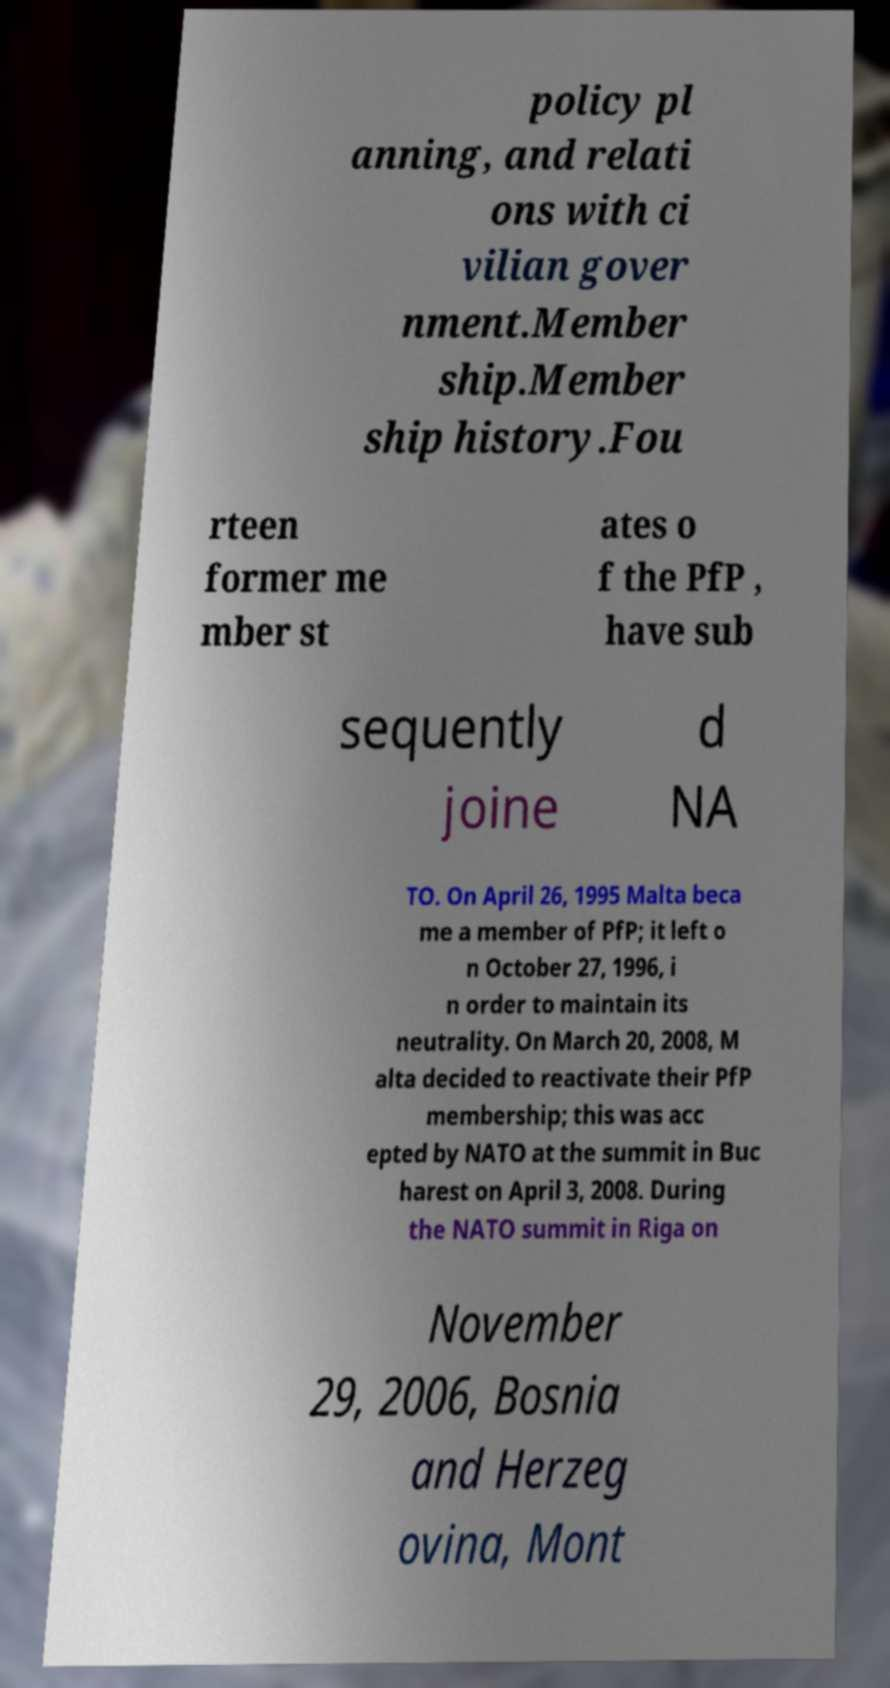Could you extract and type out the text from this image? policy pl anning, and relati ons with ci vilian gover nment.Member ship.Member ship history.Fou rteen former me mber st ates o f the PfP , have sub sequently joine d NA TO. On April 26, 1995 Malta beca me a member of PfP; it left o n October 27, 1996, i n order to maintain its neutrality. On March 20, 2008, M alta decided to reactivate their PfP membership; this was acc epted by NATO at the summit in Buc harest on April 3, 2008. During the NATO summit in Riga on November 29, 2006, Bosnia and Herzeg ovina, Mont 